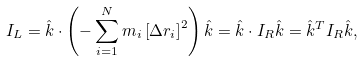<formula> <loc_0><loc_0><loc_500><loc_500>I _ { L } = \hat { k } \cdot \left ( - \sum _ { i = 1 } ^ { N } m _ { i } \left [ \Delta r _ { i } \right ] ^ { 2 } \right ) \hat { k } = \hat { k } \cdot I _ { R } \hat { k } = \hat { k } ^ { T } I _ { R } \hat { k } ,</formula> 